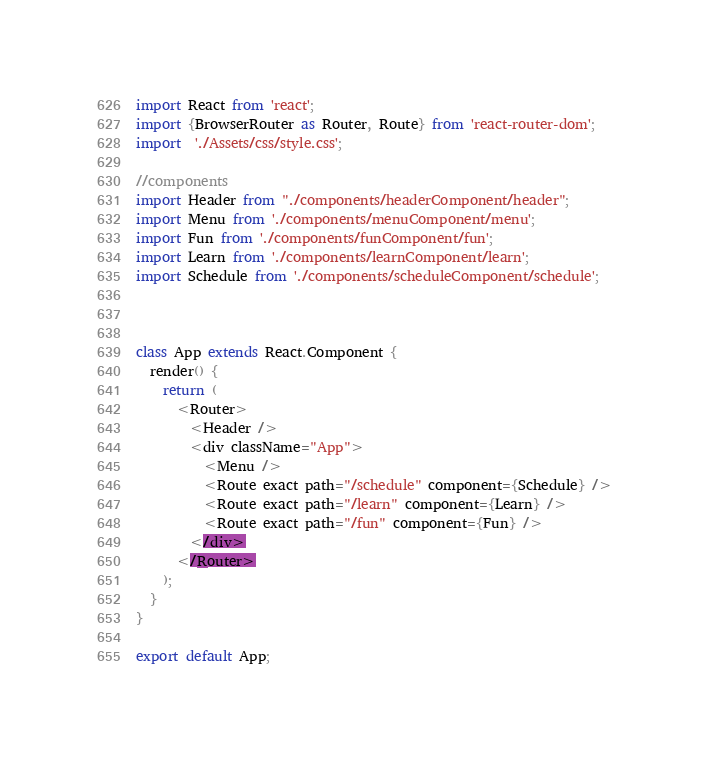Convert code to text. <code><loc_0><loc_0><loc_500><loc_500><_JavaScript_>import React from 'react';
import {BrowserRouter as Router, Route} from 'react-router-dom';
import  './Assets/css/style.css';

//components 
import Header from "./components/headerComponent/header";
import Menu from './components/menuComponent/menu';
import Fun from './components/funComponent/fun';
import Learn from './components/learnComponent/learn';
import Schedule from './components/scheduleComponent/schedule';



class App extends React.Component {
  render() {
    return (
      <Router>
        <Header />
        <div className="App">
          <Menu />
          <Route exact path="/schedule" component={Schedule} />
          <Route exact path="/learn" component={Learn} />
          <Route exact path="/fun" component={Fun} />
        </div>
      </Router>
    );
  }
}

export default App;
</code> 